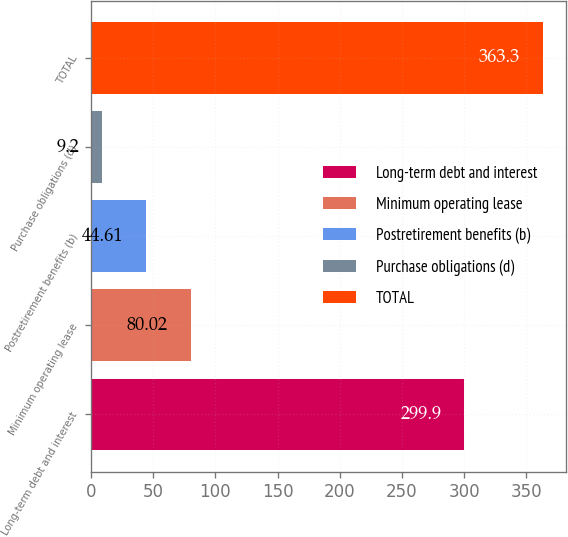<chart> <loc_0><loc_0><loc_500><loc_500><bar_chart><fcel>Long-term debt and interest<fcel>Minimum operating lease<fcel>Postretirement benefits (b)<fcel>Purchase obligations (d)<fcel>TOTAL<nl><fcel>299.9<fcel>80.02<fcel>44.61<fcel>9.2<fcel>363.3<nl></chart> 